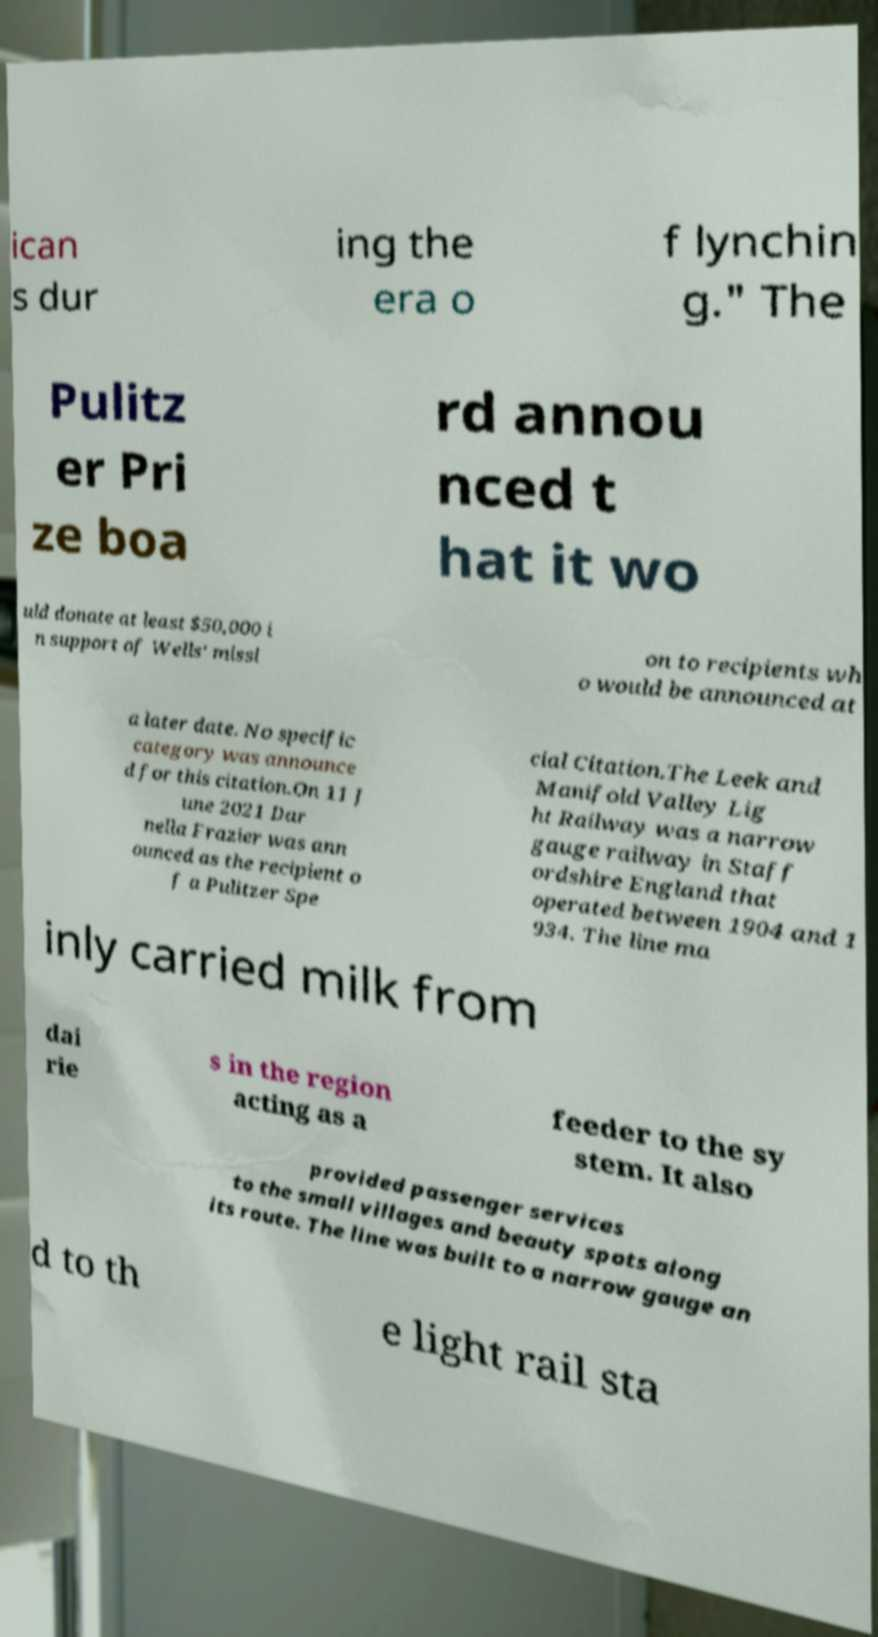Can you read and provide the text displayed in the image?This photo seems to have some interesting text. Can you extract and type it out for me? ican s dur ing the era o f lynchin g." The Pulitz er Pri ze boa rd annou nced t hat it wo uld donate at least $50,000 i n support of Wells' missi on to recipients wh o would be announced at a later date. No specific category was announce d for this citation.On 11 J une 2021 Dar nella Frazier was ann ounced as the recipient o f a Pulitzer Spe cial Citation.The Leek and Manifold Valley Lig ht Railway was a narrow gauge railway in Staff ordshire England that operated between 1904 and 1 934. The line ma inly carried milk from dai rie s in the region acting as a feeder to the sy stem. It also provided passenger services to the small villages and beauty spots along its route. The line was built to a narrow gauge an d to th e light rail sta 